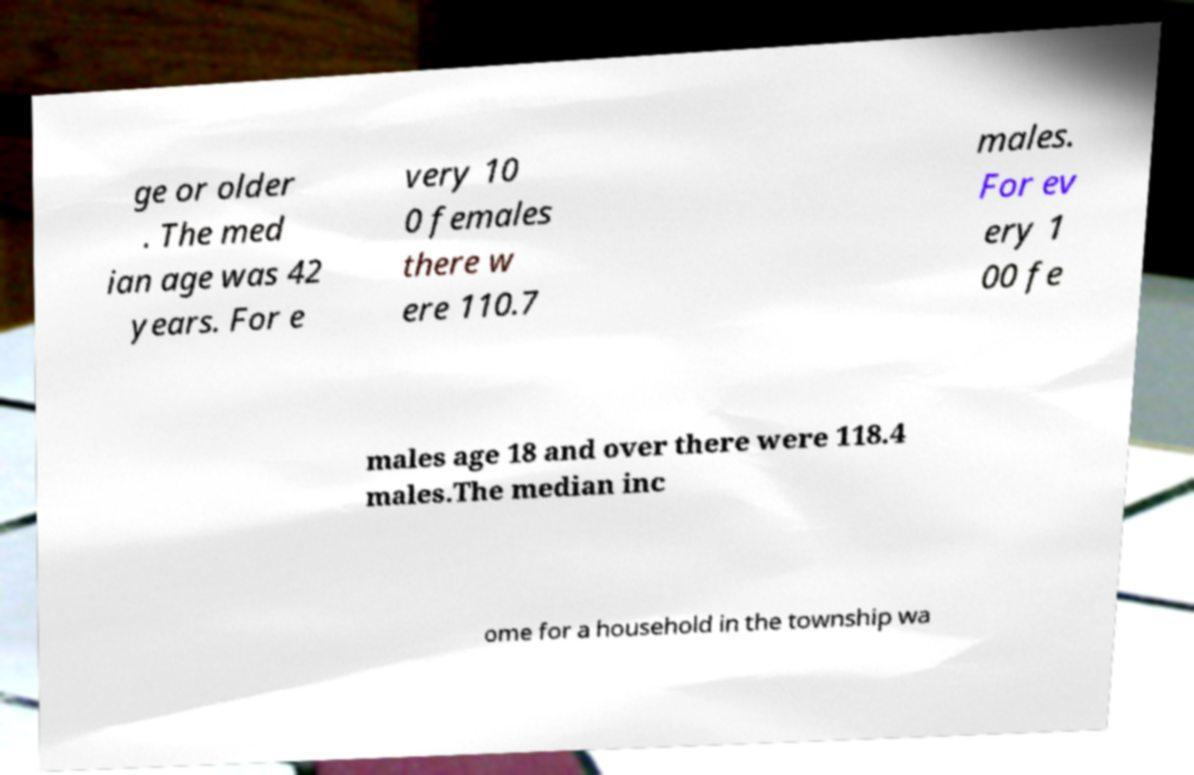Can you accurately transcribe the text from the provided image for me? ge or older . The med ian age was 42 years. For e very 10 0 females there w ere 110.7 males. For ev ery 1 00 fe males age 18 and over there were 118.4 males.The median inc ome for a household in the township wa 